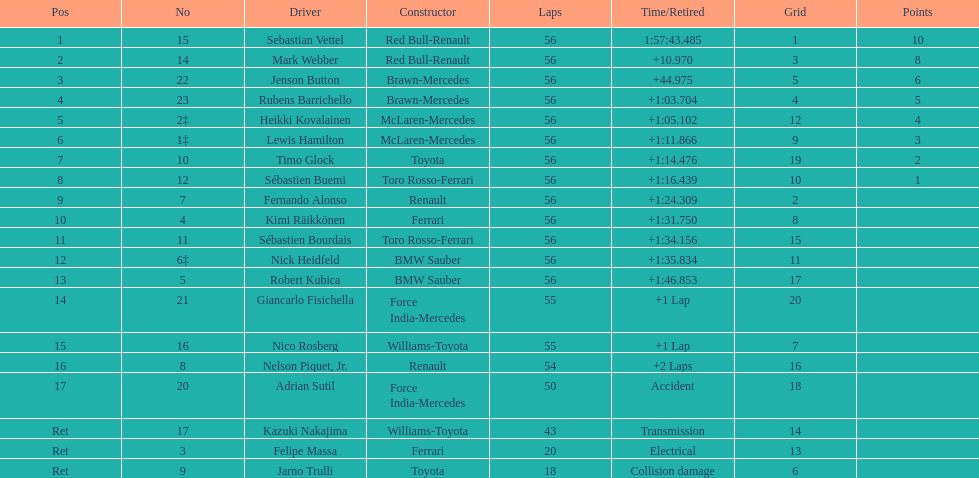What is the name of a driver for whom ferrari wasn't a constructor? Sebastian Vettel. 